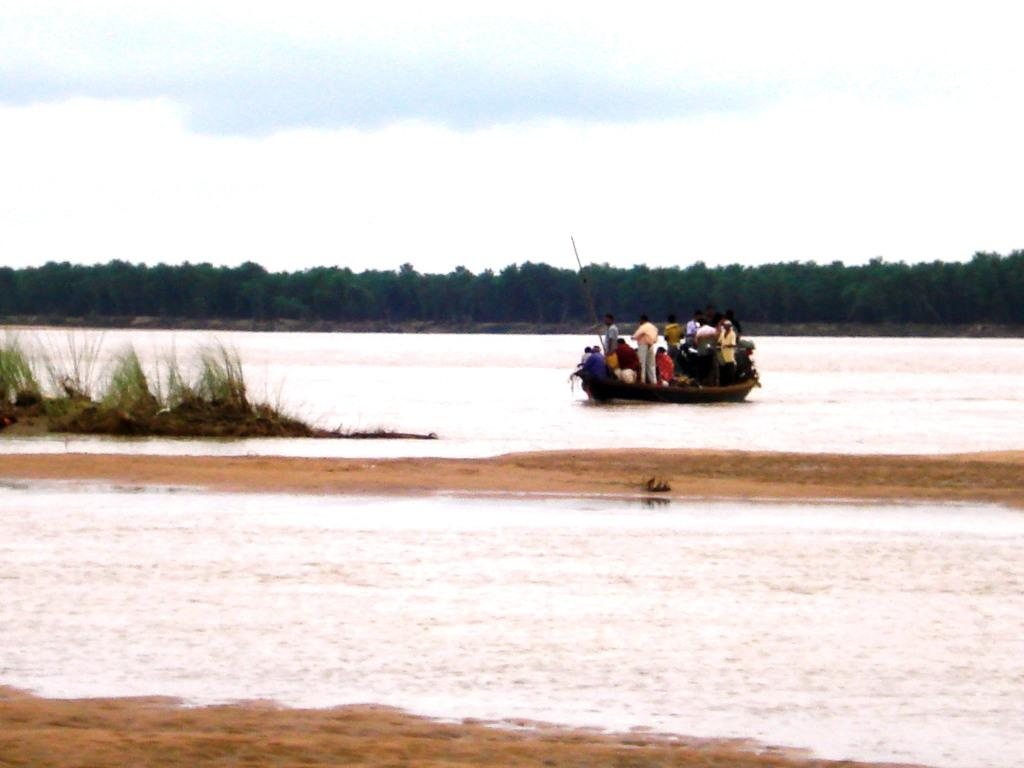What type of vegetation is present in the image? There is grass in the image. What else can be seen in the image besides grass? There is water, a group of people in a boat, trees in the background, and the sky visible in the background. What might be the setting of the image? The image appears to be taken near a lake during the day. What type of ink is being used by the people in the boat to write on the water? There is no ink or writing on the water in the image; the people in the boat are simply enjoying the lake. What flavor of jam can be seen on the trees in the background? There is no jam present in the image; the trees in the background are natural vegetation. 